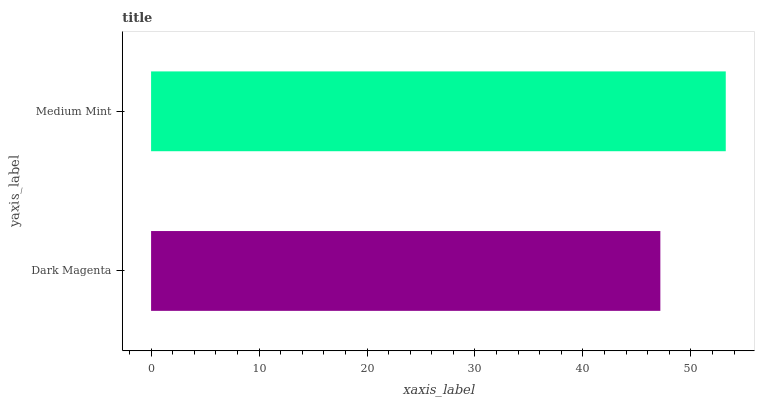Is Dark Magenta the minimum?
Answer yes or no. Yes. Is Medium Mint the maximum?
Answer yes or no. Yes. Is Medium Mint the minimum?
Answer yes or no. No. Is Medium Mint greater than Dark Magenta?
Answer yes or no. Yes. Is Dark Magenta less than Medium Mint?
Answer yes or no. Yes. Is Dark Magenta greater than Medium Mint?
Answer yes or no. No. Is Medium Mint less than Dark Magenta?
Answer yes or no. No. Is Medium Mint the high median?
Answer yes or no. Yes. Is Dark Magenta the low median?
Answer yes or no. Yes. Is Dark Magenta the high median?
Answer yes or no. No. Is Medium Mint the low median?
Answer yes or no. No. 